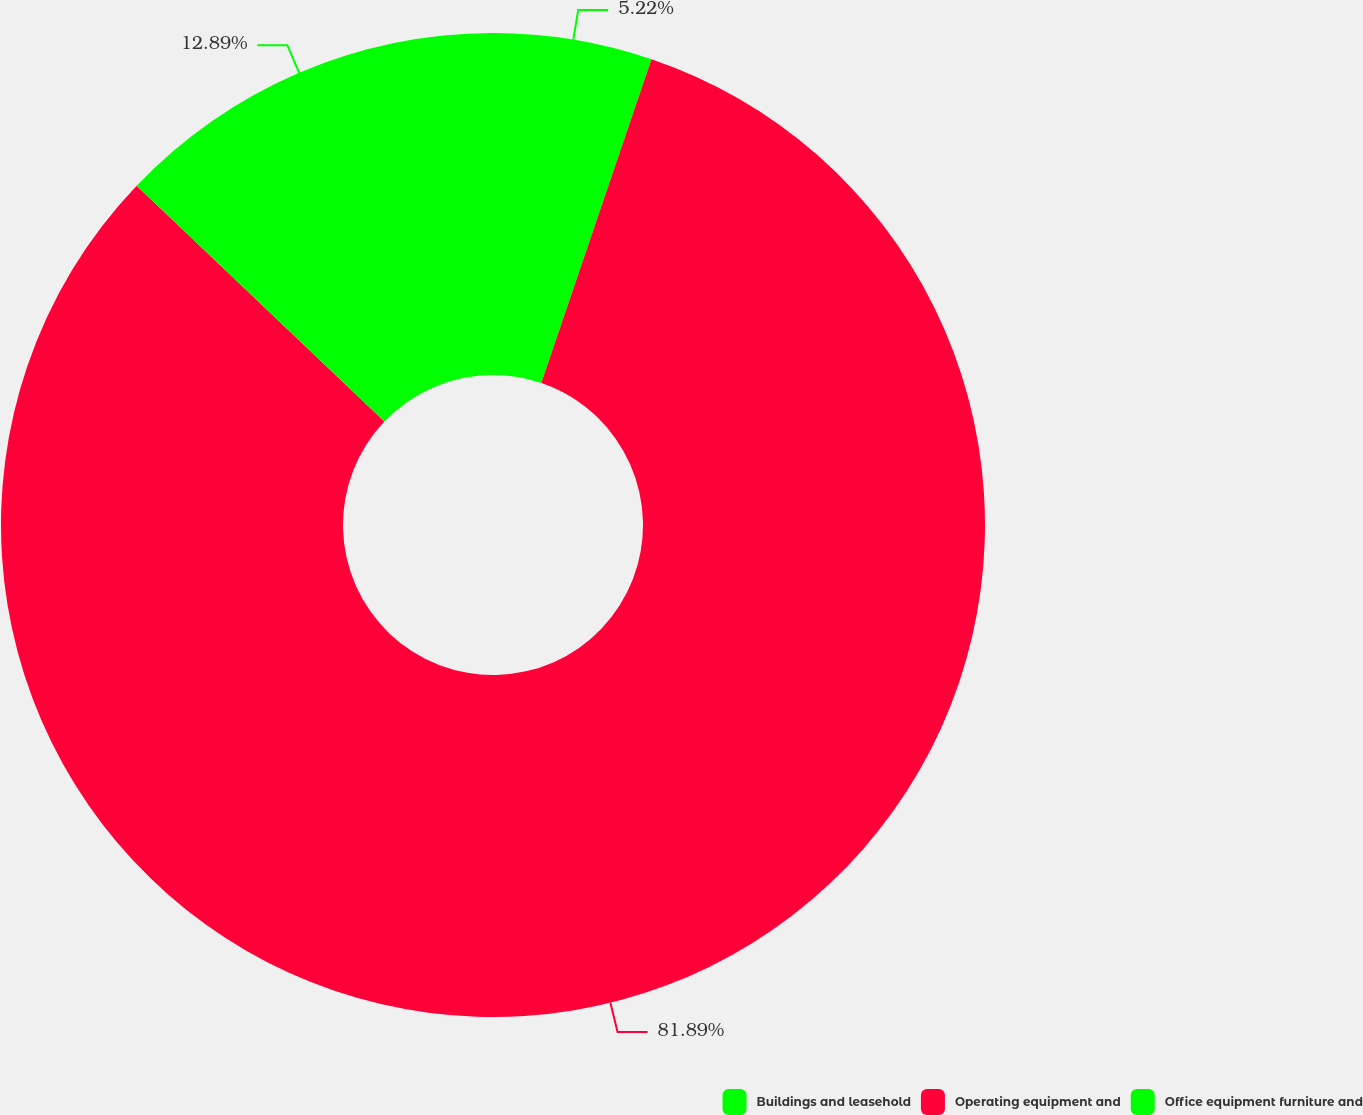<chart> <loc_0><loc_0><loc_500><loc_500><pie_chart><fcel>Buildings and leasehold<fcel>Operating equipment and<fcel>Office equipment furniture and<nl><fcel>5.22%<fcel>81.89%<fcel>12.89%<nl></chart> 